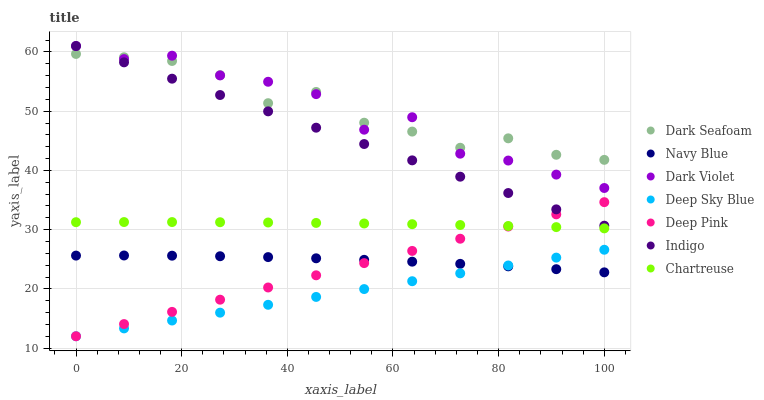Does Deep Sky Blue have the minimum area under the curve?
Answer yes or no. Yes. Does Dark Seafoam have the maximum area under the curve?
Answer yes or no. Yes. Does Indigo have the minimum area under the curve?
Answer yes or no. No. Does Indigo have the maximum area under the curve?
Answer yes or no. No. Is Deep Pink the smoothest?
Answer yes or no. Yes. Is Dark Violet the roughest?
Answer yes or no. Yes. Is Indigo the smoothest?
Answer yes or no. No. Is Indigo the roughest?
Answer yes or no. No. Does Deep Pink have the lowest value?
Answer yes or no. Yes. Does Indigo have the lowest value?
Answer yes or no. No. Does Dark Violet have the highest value?
Answer yes or no. Yes. Does Navy Blue have the highest value?
Answer yes or no. No. Is Deep Sky Blue less than Dark Seafoam?
Answer yes or no. Yes. Is Dark Seafoam greater than Deep Pink?
Answer yes or no. Yes. Does Deep Sky Blue intersect Deep Pink?
Answer yes or no. Yes. Is Deep Sky Blue less than Deep Pink?
Answer yes or no. No. Is Deep Sky Blue greater than Deep Pink?
Answer yes or no. No. Does Deep Sky Blue intersect Dark Seafoam?
Answer yes or no. No. 